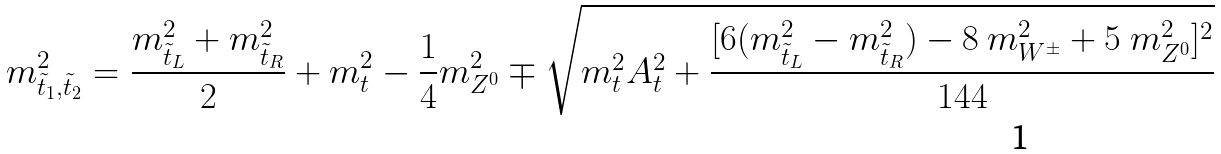Convert formula to latex. <formula><loc_0><loc_0><loc_500><loc_500>m _ { \tilde { t } _ { 1 } , \tilde { t } _ { 2 } } ^ { 2 } = { \frac { m _ { \tilde { t } _ { L } } ^ { 2 } + m _ { \tilde { t } _ { R } } ^ { 2 } } { 2 } } + m _ { t } ^ { 2 } - { \frac { 1 } { 4 } } m _ { Z ^ { 0 } } ^ { 2 } \mp \sqrt { m _ { t } ^ { 2 } A _ { t } ^ { 2 } + { \frac { [ 6 ( m _ { \tilde { t } _ { L } } ^ { 2 } - m _ { \tilde { t } _ { R } } ^ { 2 } ) - 8 \ m _ { W ^ { \pm } } ^ { 2 } + 5 \ m _ { Z ^ { 0 } } ^ { 2 } ] ^ { 2 } } { 1 4 4 } } }</formula> 